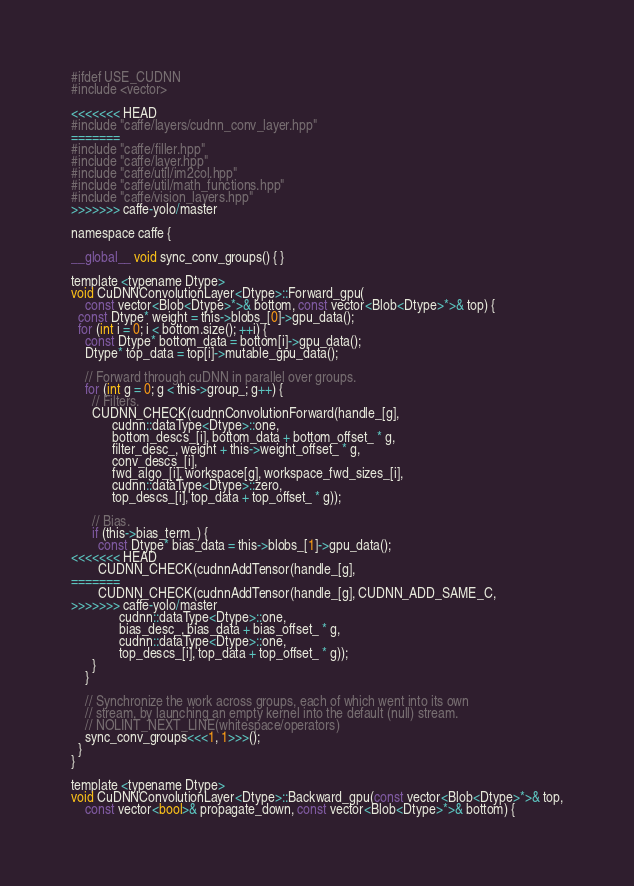Convert code to text. <code><loc_0><loc_0><loc_500><loc_500><_Cuda_>#ifdef USE_CUDNN
#include <vector>

<<<<<<< HEAD
#include "caffe/layers/cudnn_conv_layer.hpp"
=======
#include "caffe/filler.hpp"
#include "caffe/layer.hpp"
#include "caffe/util/im2col.hpp"
#include "caffe/util/math_functions.hpp"
#include "caffe/vision_layers.hpp"
>>>>>>> caffe-yolo/master

namespace caffe {

__global__ void sync_conv_groups() { }

template <typename Dtype>
void CuDNNConvolutionLayer<Dtype>::Forward_gpu(
    const vector<Blob<Dtype>*>& bottom, const vector<Blob<Dtype>*>& top) {
  const Dtype* weight = this->blobs_[0]->gpu_data();
  for (int i = 0; i < bottom.size(); ++i) {
    const Dtype* bottom_data = bottom[i]->gpu_data();
    Dtype* top_data = top[i]->mutable_gpu_data();

    // Forward through cuDNN in parallel over groups.
    for (int g = 0; g < this->group_; g++) {
      // Filters.
      CUDNN_CHECK(cudnnConvolutionForward(handle_[g],
            cudnn::dataType<Dtype>::one,
            bottom_descs_[i], bottom_data + bottom_offset_ * g,
            filter_desc_, weight + this->weight_offset_ * g,
            conv_descs_[i],
            fwd_algo_[i], workspace[g], workspace_fwd_sizes_[i],
            cudnn::dataType<Dtype>::zero,
            top_descs_[i], top_data + top_offset_ * g));

      // Bias.
      if (this->bias_term_) {
        const Dtype* bias_data = this->blobs_[1]->gpu_data();
<<<<<<< HEAD
        CUDNN_CHECK(cudnnAddTensor(handle_[g],
=======
        CUDNN_CHECK(cudnnAddTensor(handle_[g], CUDNN_ADD_SAME_C,
>>>>>>> caffe-yolo/master
              cudnn::dataType<Dtype>::one,
              bias_desc_, bias_data + bias_offset_ * g,
              cudnn::dataType<Dtype>::one,
              top_descs_[i], top_data + top_offset_ * g));
      }
    }

    // Synchronize the work across groups, each of which went into its own
    // stream, by launching an empty kernel into the default (null) stream.
    // NOLINT_NEXT_LINE(whitespace/operators)
    sync_conv_groups<<<1, 1>>>();
  }
}

template <typename Dtype>
void CuDNNConvolutionLayer<Dtype>::Backward_gpu(const vector<Blob<Dtype>*>& top,
    const vector<bool>& propagate_down, const vector<Blob<Dtype>*>& bottom) {</code> 